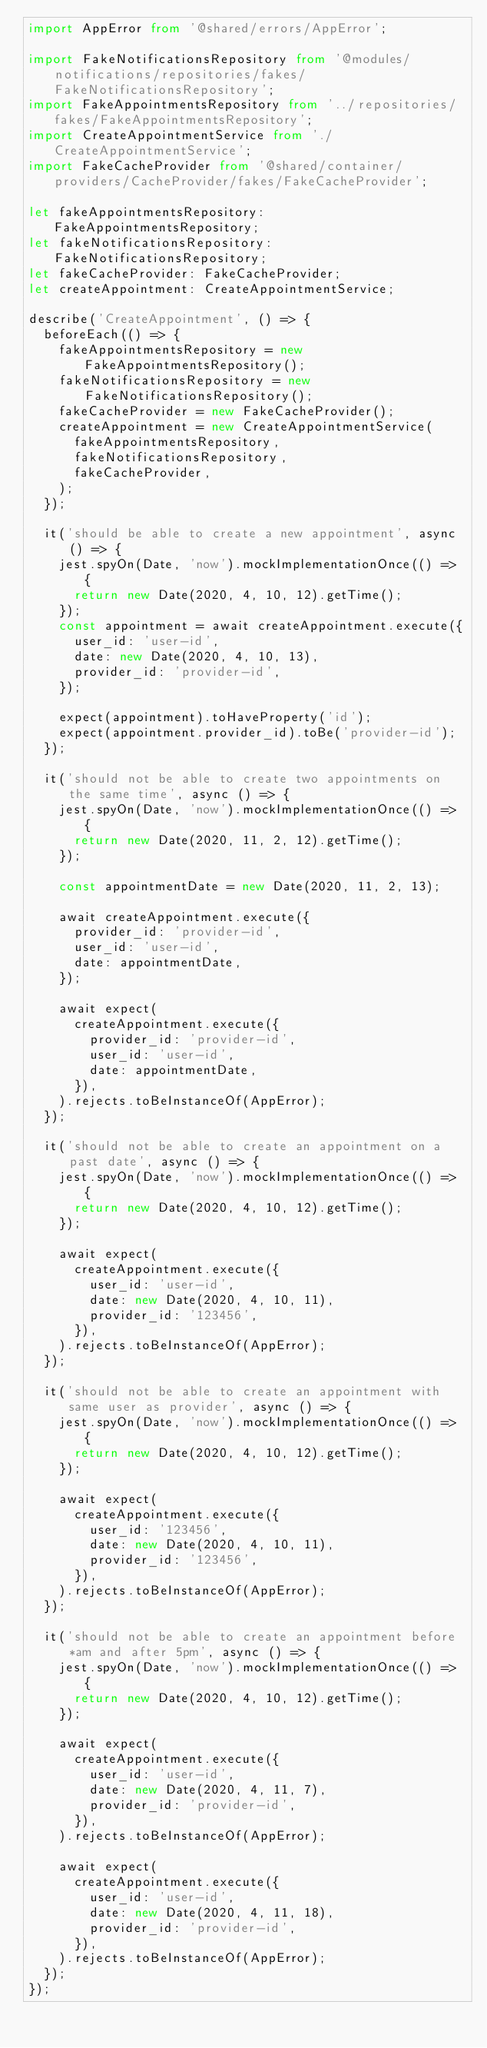<code> <loc_0><loc_0><loc_500><loc_500><_TypeScript_>import AppError from '@shared/errors/AppError';

import FakeNotificationsRepository from '@modules/notifications/repositories/fakes/FakeNotificationsRepository';
import FakeAppointmentsRepository from '../repositories/fakes/FakeAppointmentsRepository';
import CreateAppointmentService from './CreateAppointmentService';
import FakeCacheProvider from '@shared/container/providers/CacheProvider/fakes/FakeCacheProvider';

let fakeAppointmentsRepository: FakeAppointmentsRepository;
let fakeNotificationsRepository: FakeNotificationsRepository;
let fakeCacheProvider: FakeCacheProvider;
let createAppointment: CreateAppointmentService;

describe('CreateAppointment', () => {
  beforeEach(() => {
    fakeAppointmentsRepository = new FakeAppointmentsRepository();
    fakeNotificationsRepository = new FakeNotificationsRepository();
    fakeCacheProvider = new FakeCacheProvider();
    createAppointment = new CreateAppointmentService(
      fakeAppointmentsRepository,
      fakeNotificationsRepository,
      fakeCacheProvider,
    );
  });

  it('should be able to create a new appointment', async () => {
    jest.spyOn(Date, 'now').mockImplementationOnce(() => {
      return new Date(2020, 4, 10, 12).getTime();
    });
    const appointment = await createAppointment.execute({
      user_id: 'user-id',
      date: new Date(2020, 4, 10, 13),
      provider_id: 'provider-id',
    });

    expect(appointment).toHaveProperty('id');
    expect(appointment.provider_id).toBe('provider-id');
  });

  it('should not be able to create two appointments on the same time', async () => {
    jest.spyOn(Date, 'now').mockImplementationOnce(() => {
      return new Date(2020, 11, 2, 12).getTime();
    });

    const appointmentDate = new Date(2020, 11, 2, 13);

    await createAppointment.execute({
      provider_id: 'provider-id',
      user_id: 'user-id',
      date: appointmentDate,
    });

    await expect(
      createAppointment.execute({
        provider_id: 'provider-id',
        user_id: 'user-id',
        date: appointmentDate,
      }),
    ).rejects.toBeInstanceOf(AppError);
  });

  it('should not be able to create an appointment on a past date', async () => {
    jest.spyOn(Date, 'now').mockImplementationOnce(() => {
      return new Date(2020, 4, 10, 12).getTime();
    });

    await expect(
      createAppointment.execute({
        user_id: 'user-id',
        date: new Date(2020, 4, 10, 11),
        provider_id: '123456',
      }),
    ).rejects.toBeInstanceOf(AppError);
  });

  it('should not be able to create an appointment with same user as provider', async () => {
    jest.spyOn(Date, 'now').mockImplementationOnce(() => {
      return new Date(2020, 4, 10, 12).getTime();
    });

    await expect(
      createAppointment.execute({
        user_id: '123456',
        date: new Date(2020, 4, 10, 11),
        provider_id: '123456',
      }),
    ).rejects.toBeInstanceOf(AppError);
  });

  it('should not be able to create an appointment before *am and after 5pm', async () => {
    jest.spyOn(Date, 'now').mockImplementationOnce(() => {
      return new Date(2020, 4, 10, 12).getTime();
    });

    await expect(
      createAppointment.execute({
        user_id: 'user-id',
        date: new Date(2020, 4, 11, 7),
        provider_id: 'provider-id',
      }),
    ).rejects.toBeInstanceOf(AppError);

    await expect(
      createAppointment.execute({
        user_id: 'user-id',
        date: new Date(2020, 4, 11, 18),
        provider_id: 'provider-id',
      }),
    ).rejects.toBeInstanceOf(AppError);
  });
});
</code> 